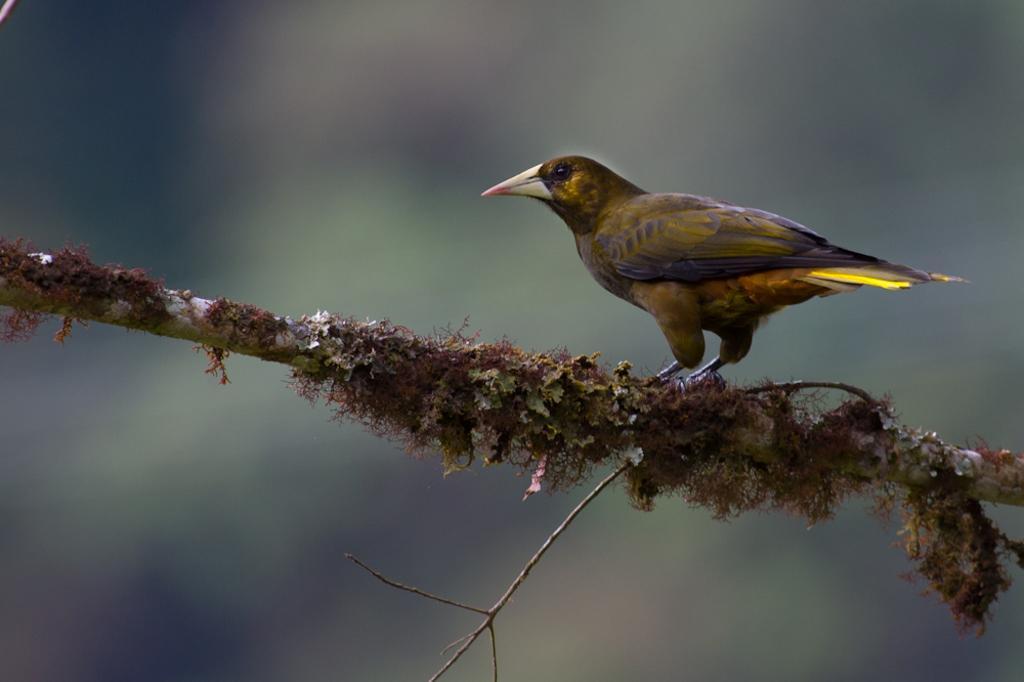How would you summarize this image in a sentence or two? In this image we can see a bird. There is a wooden object in the image. There is a blur background in the image. 